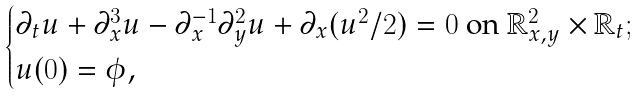Convert formula to latex. <formula><loc_0><loc_0><loc_500><loc_500>\begin{cases} \partial _ { t } u + \partial _ { x } ^ { 3 } u - \partial _ { x } ^ { - 1 } \partial _ { y } ^ { 2 } u + \partial _ { x } ( u ^ { 2 } / 2 ) = 0 \text { on } \mathbb { R } ^ { 2 } _ { x , y } \times \mathbb { R } _ { t } ; \\ u ( 0 ) = \phi , \end{cases}</formula> 